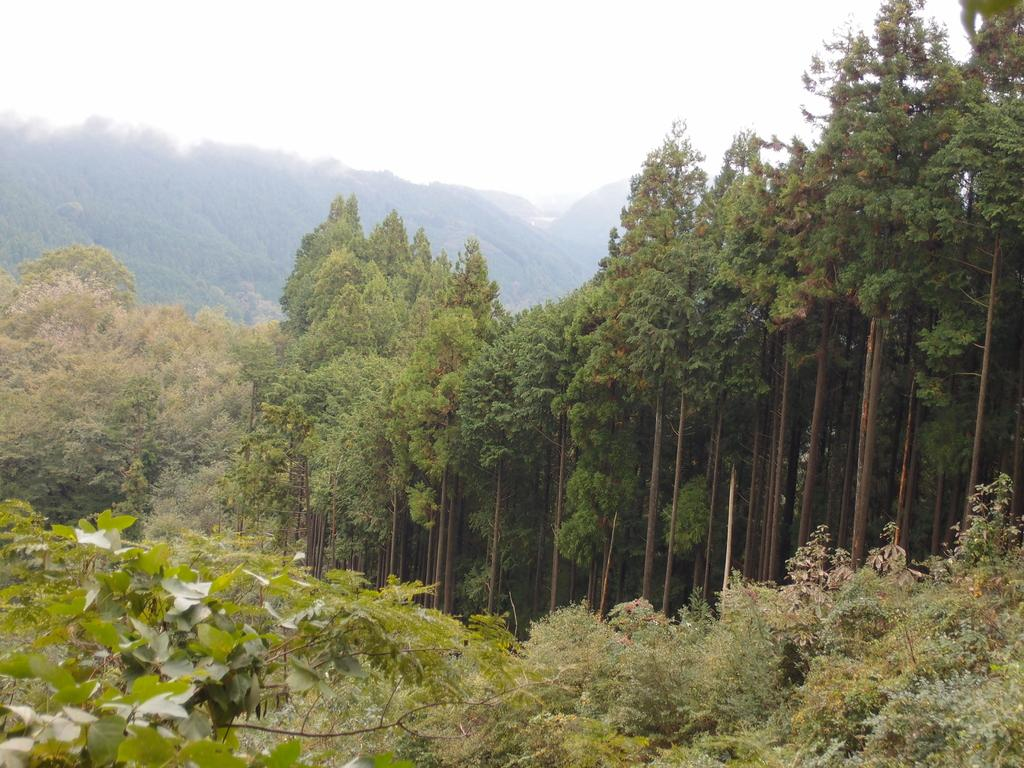What type of natural elements can be seen in the image? There are trees and plants visible in the image. What is visible in the background of the image? The sky and mountains are visible in the background of the image. How would you describe the sky in the image? The sky appears to be cloudy in the image. Is there a person driving a car in the image? There is no car or person driving in the image. What type of suit is the person wearing while standing in the rainstorm in the image? There is no person or rainstorm present in the image. 